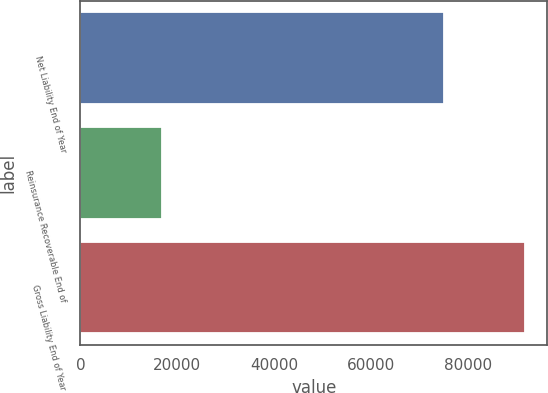Convert chart to OTSL. <chart><loc_0><loc_0><loc_500><loc_500><bar_chart><fcel>Net Liability End of Year<fcel>Reinsurance Recoverable End of<fcel>Gross Liability End of Year<nl><fcel>75029<fcel>16803<fcel>91832<nl></chart> 